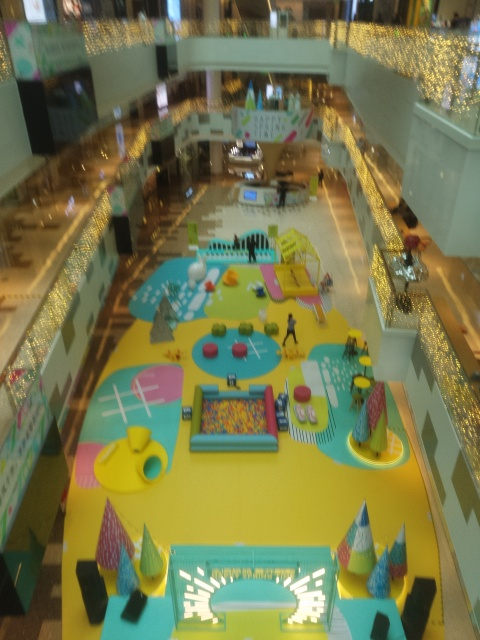What kind of location does this image show? The image displays an indoor area, likely a multi-story shopping mall or an event space. The space features a whimsical, colorful design with various installations that could serve as playground or activity areas. It looks like a space designed for family entertainment or a festive event. Are there any specific features that make this space unique? Indeed, the vibrant yellow flooring stands out, creating a strong visual contrast with colorful patterns and playful elements. One can see areas resembling game boards, slides, and ball pits, which are not commonly found in typical mall settings, indicating creativity in the design intended to engage visitors, especially children. 